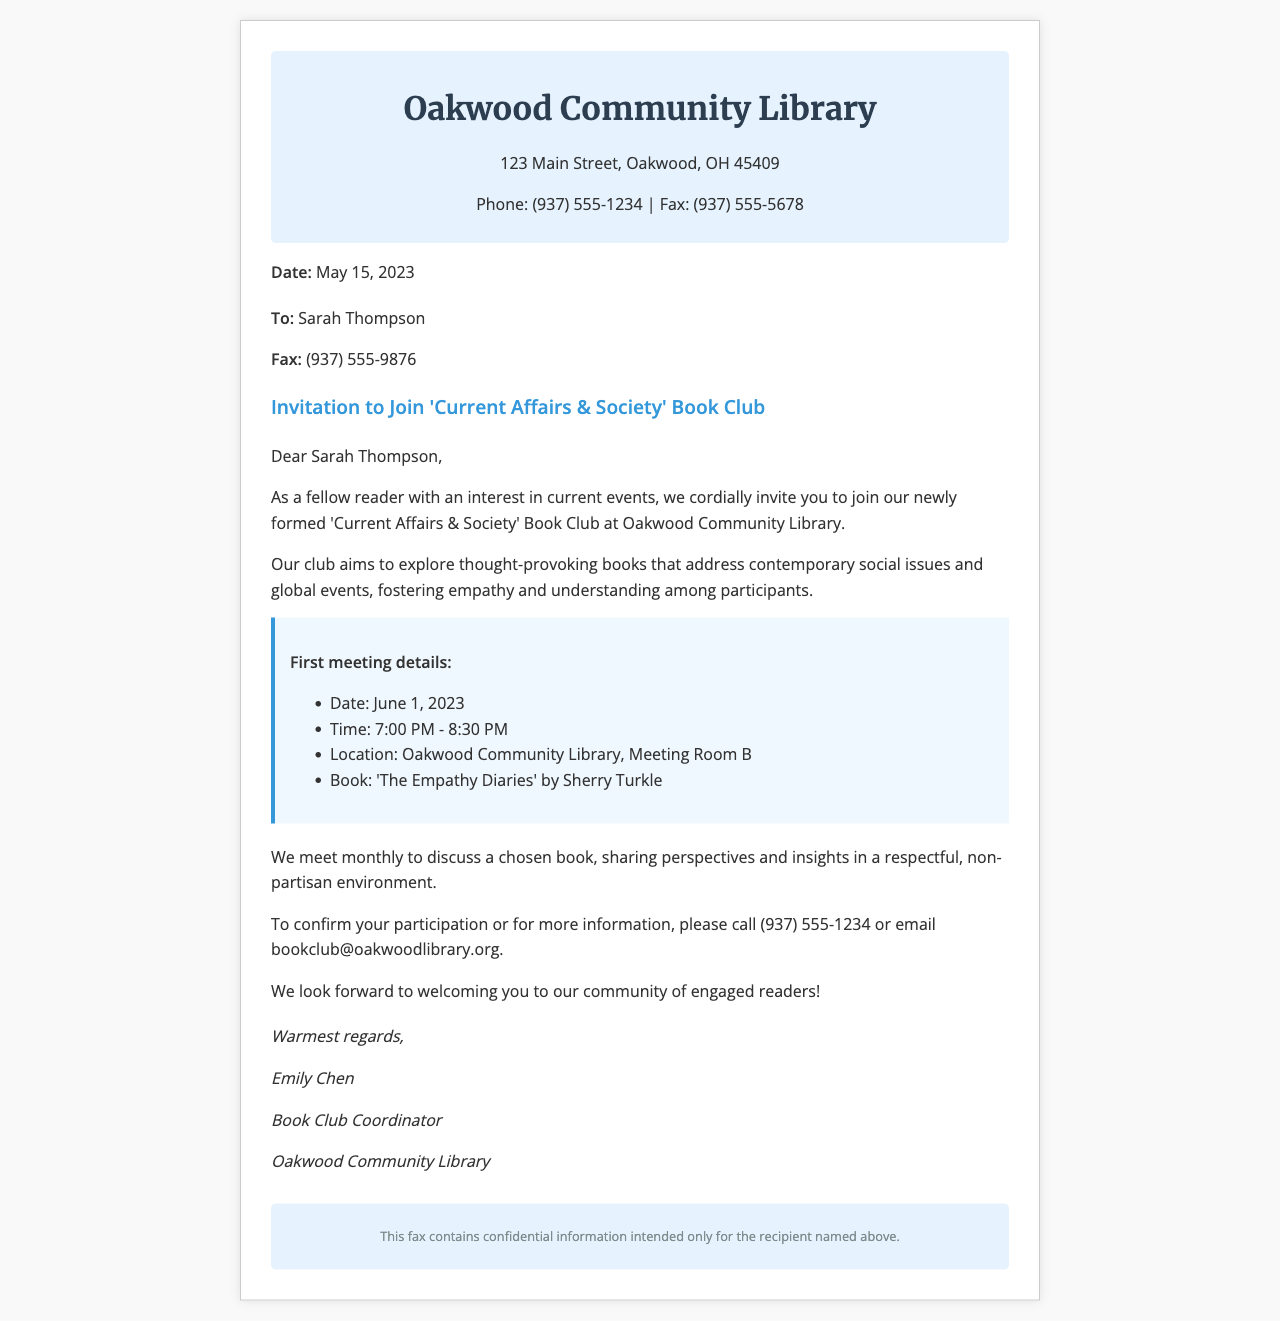What is the date of the first meeting? The date of the first meeting is mentioned in the meeting details section of the document.
Answer: June 1, 2023 Who is the sender of the fax? The sender of the fax is identified in the signature section, where the name and role are provided.
Answer: Emily Chen What is the main topic of the book club? The document specifies the focus of the book club in the body section.
Answer: Current Affairs & Society Where will the book club meet? The location of the book club is mentioned in the meeting details section.
Answer: Oakwood Community Library, Meeting Room B What book will be discussed at the first meeting? The specific book to be discussed is listed in the meeting details.
Answer: The Empathy Diaries How often does the book club meet? The frequency of the meetings is stated in the body of the document.
Answer: Monthly What is the phone number for confirmation? The document provides a phone number for confirming participation.
Answer: (937) 555-1234 What is the purpose of the book club? The purpose is articulated in the body section of the document.
Answer: Foster empathy and understanding What is the intended audience for this invitation? The intended recipient is implied through the salutation and context of the invitation.
Answer: Sarah Thompson 